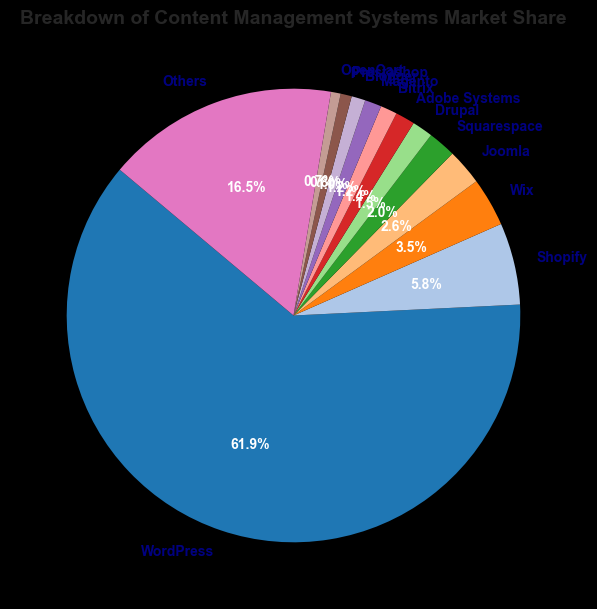what is the largest slice in the pie chart? Looking at the pie chart, the largest slice can be identified visually as the one that takes up the most space. Since WordPress has the highest market share of 62.5%, it is the largest slice.
Answer: WordPress which CMS has a larger market share, Shopify or Wix? To compare the market shares of Shopify and Wix, we look at their respective slices in the pie chart. Shopify has a market share of 5.9%, while Wix has a market share of 3.5%. Thus, Shopify has a larger market share than Wix.
Answer: Shopify what is the combined market share of Joomla and Squarespace? To find the combined market share, we add the market shares of Joomla and Squarespace. Joomla has 2.6% and Squarespace has 2.0%. Adding these together gives 2.6% + 2.0% = 4.6%.
Answer: 4.6% how much greater is the market share of WordPress compared to Drupal? To determine how much greater the market share of WordPress is compared to Drupal, we subtract the market share of Drupal from that of WordPress. WordPress has 62.5% and Drupal has 1.5%. Thus, 62.5% - 1.5% = 61.0%.
Answer: 61.0% which CMSs have market shares less than Adobe Systems? By inspecting the pie chart, we see that Adobe Systems has a market share of 1.4%. CMSs with market shares less than Adobe Systems are Blogger (1.0%), Prestashop (0.8%), and OpenCart (0.7%), concluding with the 'Others' category combined.
Answer: Blogger, Prestashop, OpenCart, Others what percentage of the market share do the top three CMSs constitute? The top three CMSs by market share are WordPress, Shopify, and Wix. Summing their market shares, we get 62.5% (WordPress) + 5.9% (Shopify) + 3.5% (Wix) = 71.9%.
Answer: 71.9% which CMS has the smallest market share? By examining the pie chart, the CMS with the smallest market share is OpenCart at 0.7%.
Answer: OpenCart what is the total market share of CMSs other than WordPress? To find the total market share of CMSs other than WordPress, we subtract WordPress’s market share from 100%. So, 100% - 62.5% = 37.5%.
Answer: 37.5% what is the visual color used for the slice representing Magento's market share? The slice representing Magento has a distinct color for easy identification. Referring to the color scheme used (plt.cm.tab20.colors), Magento's slice is depicted in a specific color, which would be visually recognizable. Assuming it follows the pattern as usual, Magento is likely to be in a mid-palette color.
Answer: Mid-palette color (usually a shade of purple or blue in tab20) 